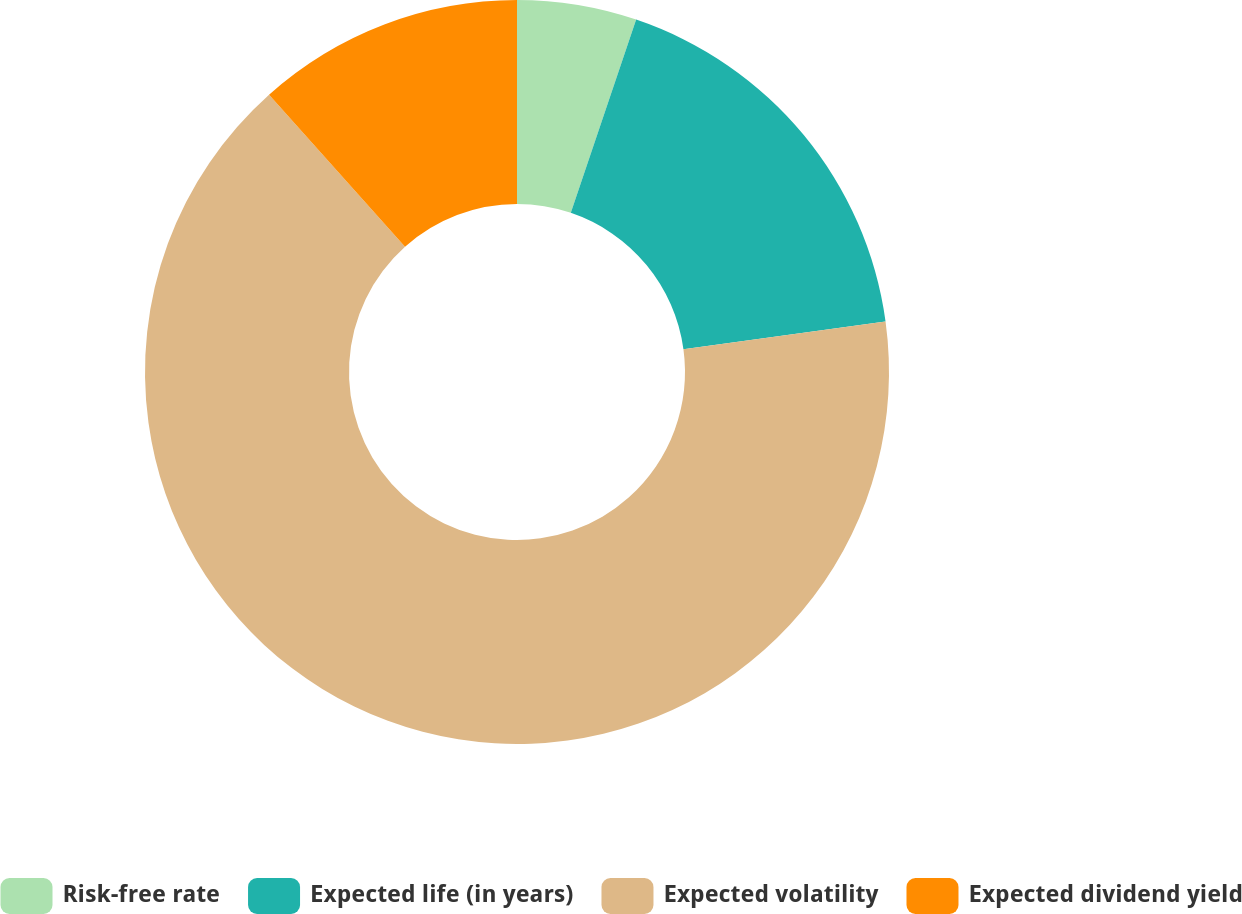Convert chart to OTSL. <chart><loc_0><loc_0><loc_500><loc_500><pie_chart><fcel>Risk-free rate<fcel>Expected life (in years)<fcel>Expected volatility<fcel>Expected dividend yield<nl><fcel>5.19%<fcel>17.64%<fcel>65.56%<fcel>11.61%<nl></chart> 